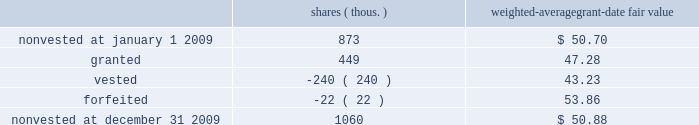Changes in our performance retention awards during 2009 were as follows : shares ( thous. ) weighted-average grant-date fair value .
At december 31 , 2009 , there was $ 22 million of total unrecognized compensation expense related to nonvested performance retention awards , which is expected to be recognized over a weighted-average period of 1.3 years .
A portion of this expense is subject to achievement of the roic levels established for the performance stock unit grants .
Retirement plans pension and other postretirement benefits pension plans 2013 we provide defined benefit retirement income to eligible non-union employees through qualified and non-qualified ( supplemental ) pension plans .
Qualified and non-qualified pension benefits are based on years of service and the highest compensation during the latest years of employment , with specific reductions made for early retirements .
Other postretirement benefits ( opeb ) 2013 we provide defined contribution medical and life insurance benefits for eligible retirees .
These benefits are funded as medical claims and life insurance premiums are plan amendment effective january 1 , 2010 , medicare-eligible retirees who are enrolled in the union pacific retiree medical program will receive a contribution to a health reimbursement account , which can be used to pay eligible out-of-pocket medical expenses .
The impact of the plan amendment is reflected in the projected benefit obligation ( pbo ) at december 31 , 2009 .
Funded status we are required by gaap to separately recognize the overfunded or underfunded status of our pension and opeb plans as an asset or liability .
The funded status represents the difference between the pbo and the fair value of the plan assets .
The pbo is the present value of benefits earned to date by plan participants , including the effect of assumed future salary increases .
The pbo of the opeb plan is equal to the accumulated benefit obligation , as the present value of the opeb liabilities is not affected by salary increases .
Plan assets are measured at fair value .
We use a december 31 measurement date for plan assets and obligations for all our retirement plans. .
At december 31 , 2009 , what was the remaining compensation expense per share for the unvested awards? 
Computations: ((22 * 1000000) / (1060 * 1000))
Answer: 20.75472. 